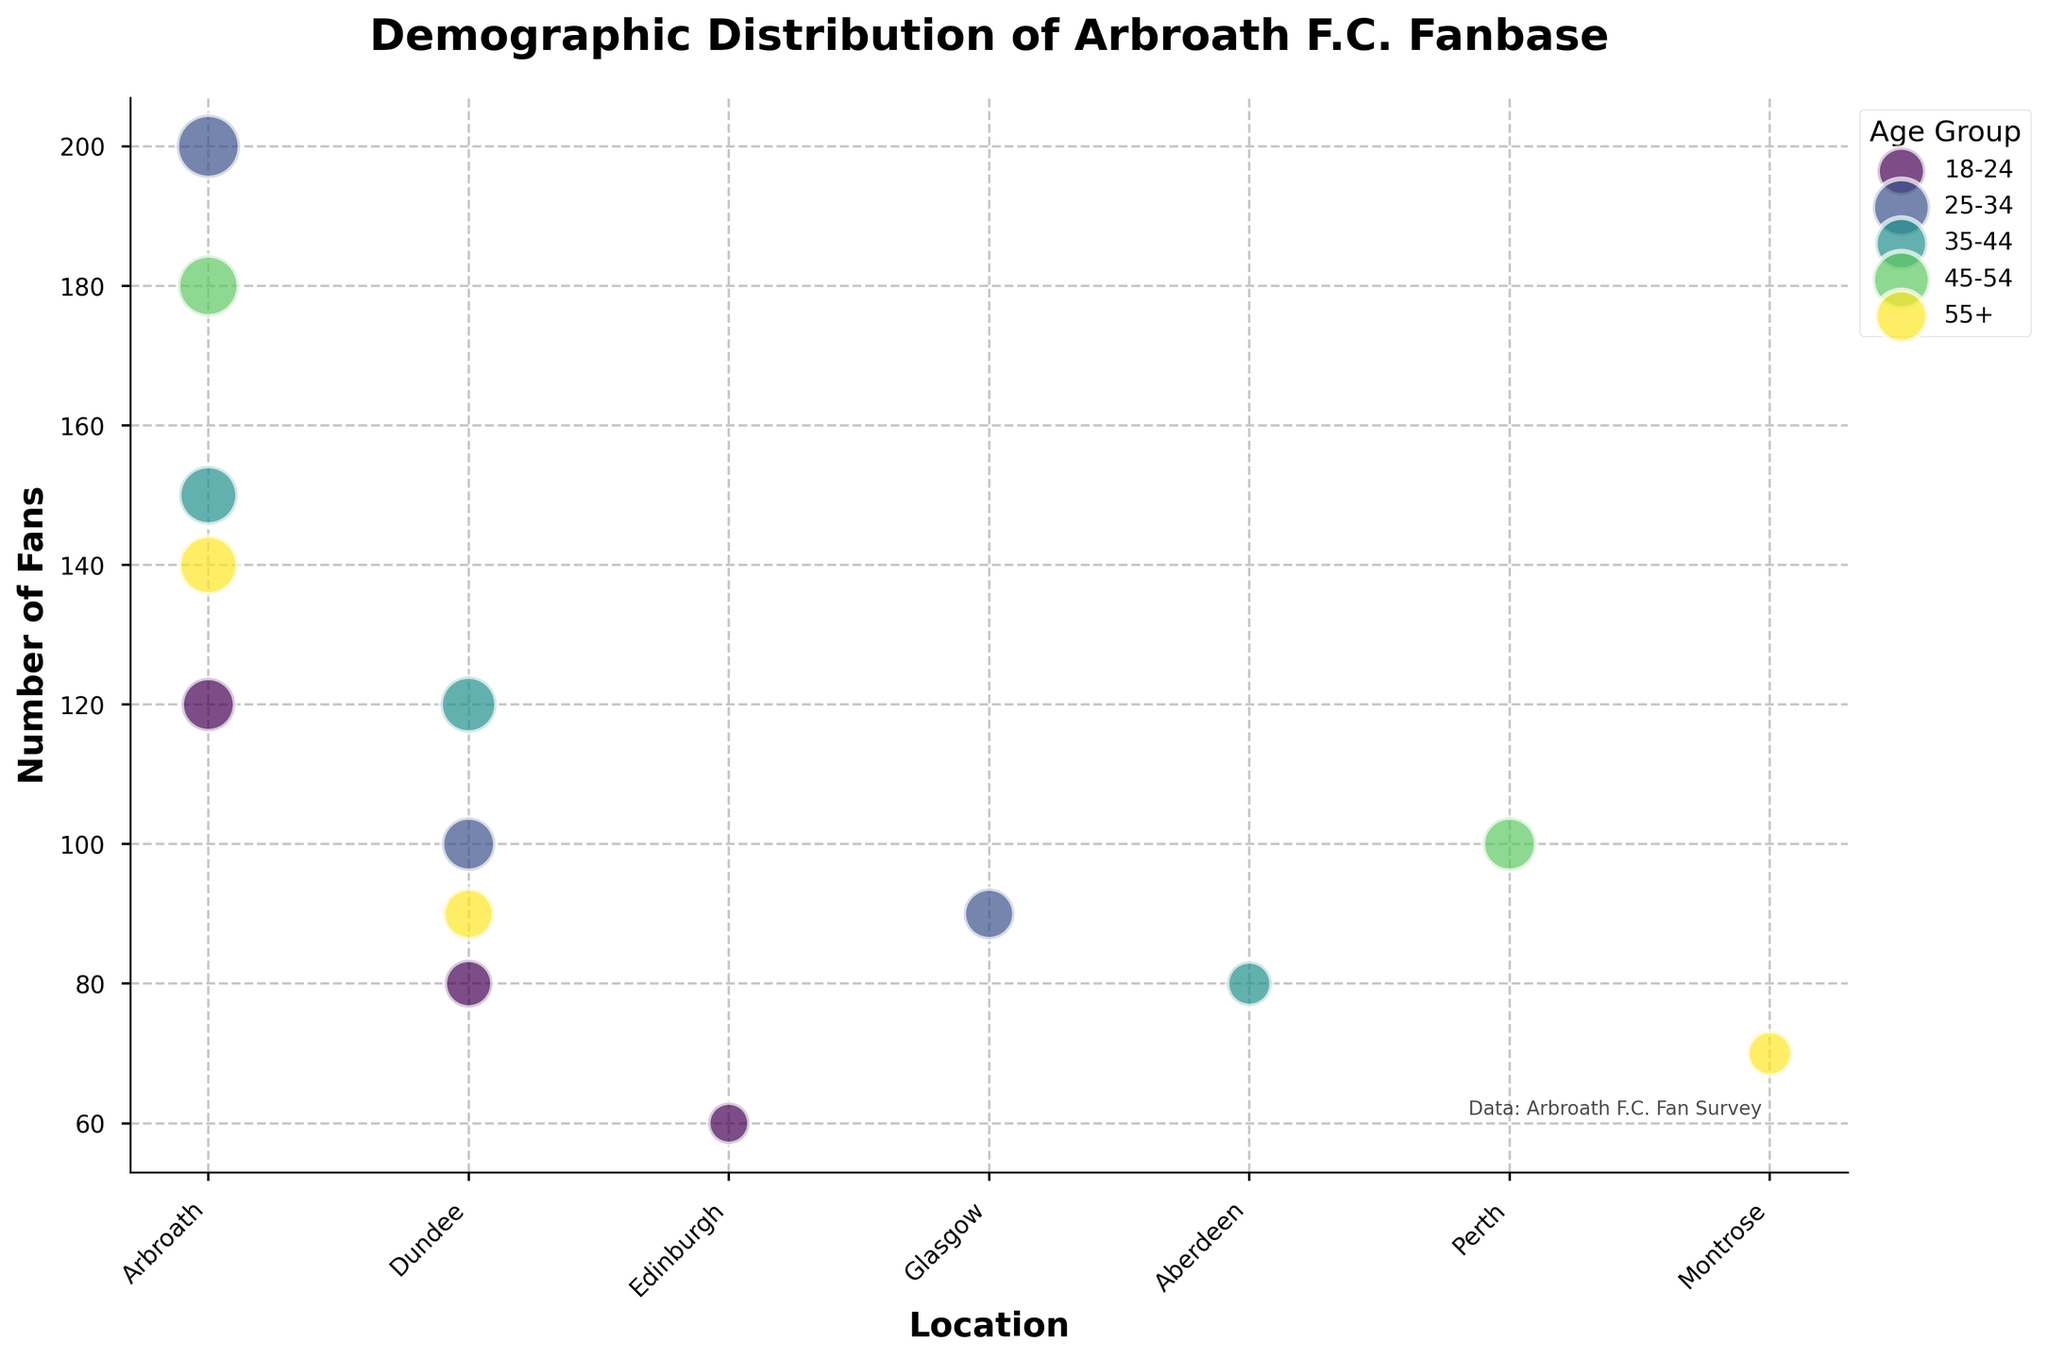What is the title of the figure? The title of the figure is typically located at the top and is clearly stated.
Answer: Demographic Distribution of Arbroath F.C. Fanbase Which age group has the largest fanbase in Arbroath? To determine this, look for the data points in Arbroath and compare the number of fans for each age group using the bubble sizes. The largest bubble size represents the biggest fanbase.
Answer: 25-34 How many fans in total are there in Dundee according to the chart? Sum the number of fans from all age groups represented in Dundee. That means adding the fans from 18-24, 25-34, 35-44, and 55+ age groups.
Answer: 390 Which location has the highest number of fans in the 35-44 age group? Check the bubbles corresponding to the 35-44 age group and compare the sizes for different locations. The largest bubble indicates the highest number of fans.
Answer: Arbroath How do the 45-54 age group's number of fans in Perth compare to those in Arbroath? Compare the bubble sizes for the 45-54 age group in both locations. Arbroath has a significantly larger bubble compared to Perth.
Answer: Arbroath has more fans What is the smallest location in terms of fanbase size for the 25-34 age group? Identify the smallest bubble size for the 25-34 age group across all locations.
Answer: Glasgow Looking at the data, which age group appears most consistently across the locations? This involves looking at the number of locations each age group appears in and determining which has the most appearances.
Answer: 25-34 Which location has a middle-sized fanbase in the 55+ age group? Compare the bubble sizes for the 55+ age group, identifying the midpoint bubble size that isn't the smallest or the largest.
Answer: Dundee What's the total number of fans for the 35-44 age group in all locations combined? Add the number of fans from each location for the 35-44 age group: Arbroath, Dundee, and Aberdeen.
Answer: 350 How does the fanbase number in the 18-24 age group in Edinburgh compare to Dundee? Compare the bubble sizes for the 18-24 age group between Edinburgh and Dundee.
Answer: Dundee has more fans 